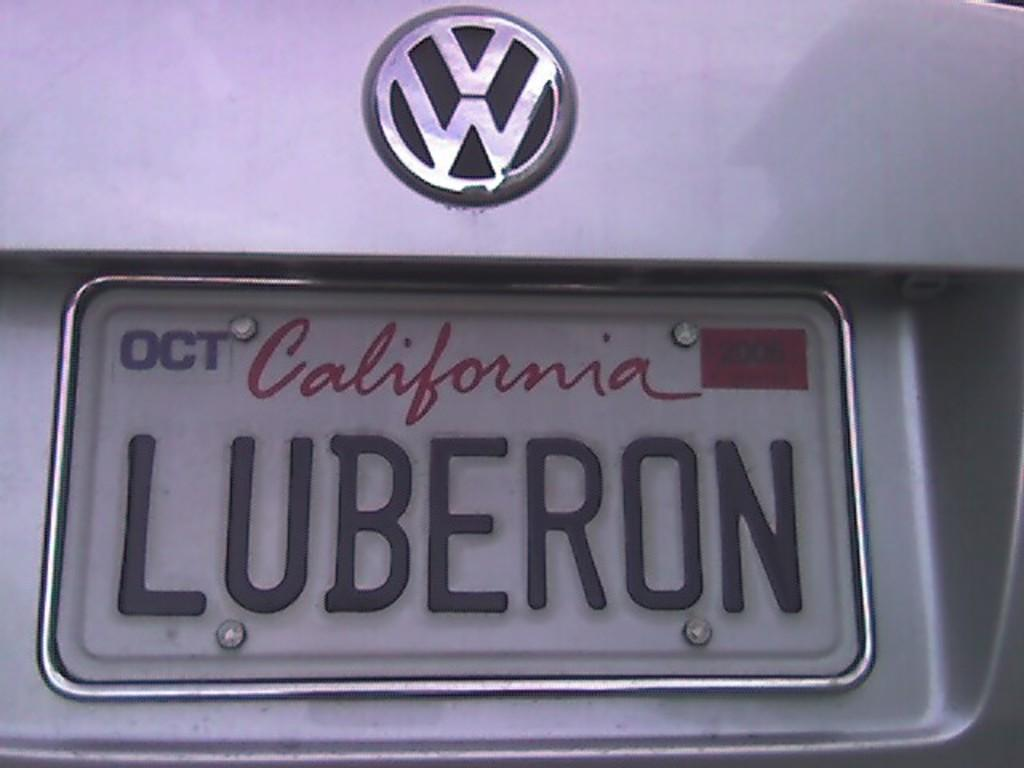<image>
Summarize the visual content of the image. a Luberon sign that is on a car 